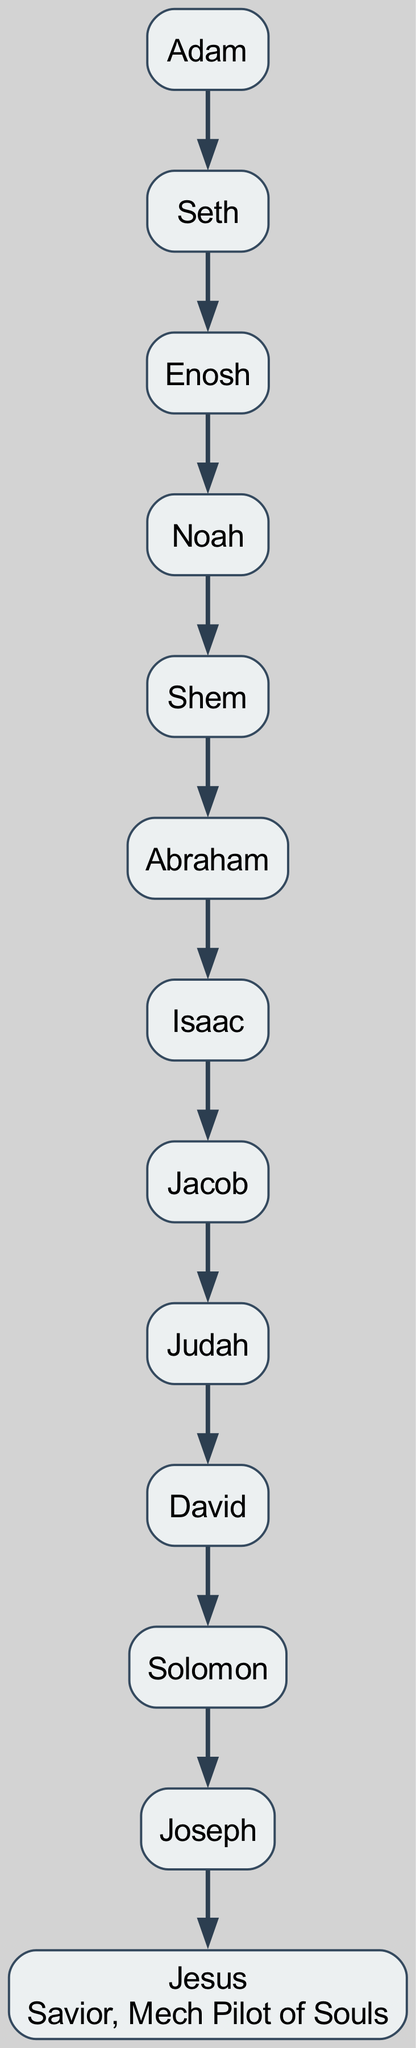What is the first name in the ancestry? The first name listed in the ancestry tree is "Adam." This is the root of the family tree, serving as the starting point of the lineage.
Answer: Adam Who is the father of Noah? According to the diagram, the parent of Noah is Enosh, who is listed as Noah's immediate ancestor in the lineage.
Answer: Enosh How many generations are displayed from Adam to Jesus? The ancestry shows a total of 11 generations starting from Adam and concluding with Jesus. By counting each name listed in the hierarchy, we confirm the number of generations.
Answer: 11 What relationship does David have to Judah? David is the son of Judah, as depicted in the family tree. This hierarchical relationship indicates that Judah is one generation up from David.
Answer: Son Who is the immediate ancestor of Solomon? The diagram indicates that Solomon's immediate ancestor is David. This means that Solomon is the next in line after David, making David the father of Solomon.
Answer: David Which figure is identified as "Savior, Mech Pilot of Souls"? The diagram specifically names Jesus and adds a description beneath his name stating "Savior, Mech Pilot of Souls." This is a unique title associated with him in the family tree.
Answer: Jesus What is the relation between Abraham and Isaac? The relationship is that Isaac is the son of Abraham, as shown in the lineage right after Abraham. This parental connection is a fundamental aspect of the diagram.
Answer: Son How many children does Noah have according to this tree? Noah has one child listed in the diagram, which is Shem. The tree indicates only this one lineage extending from Noah to future generations.
Answer: 1 Who comes directly after Jacob in the ancestry? In the family tree, Judah comes directly after Jacob, indicating that Judah is the next generation following Jacob in this lineage.
Answer: Judah 